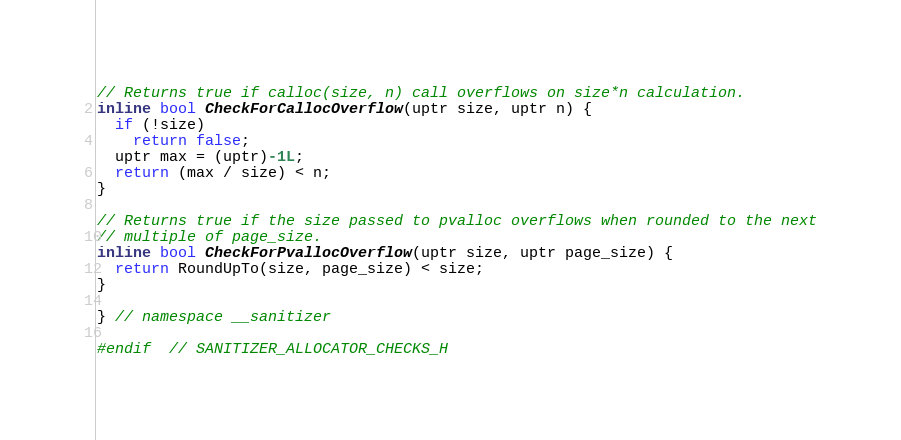Convert code to text. <code><loc_0><loc_0><loc_500><loc_500><_C_>
// Returns true if calloc(size, n) call overflows on size*n calculation.
inline bool CheckForCallocOverflow(uptr size, uptr n) {
  if (!size)
    return false;
  uptr max = (uptr)-1L;
  return (max / size) < n;
}

// Returns true if the size passed to pvalloc overflows when rounded to the next
// multiple of page_size.
inline bool CheckForPvallocOverflow(uptr size, uptr page_size) {
  return RoundUpTo(size, page_size) < size;
}

} // namespace __sanitizer

#endif  // SANITIZER_ALLOCATOR_CHECKS_H
</code> 